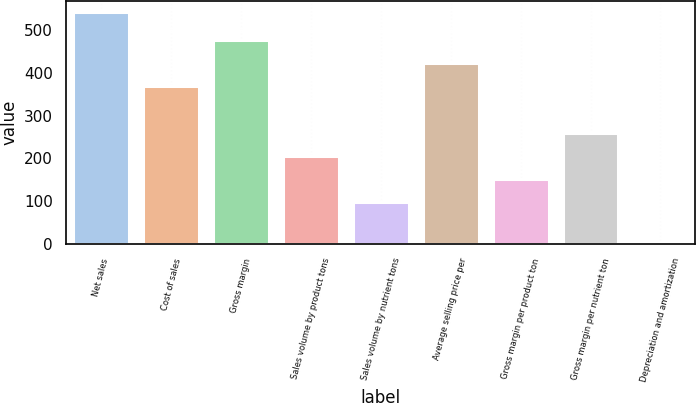Convert chart. <chart><loc_0><loc_0><loc_500><loc_500><bar_chart><fcel>Net sales<fcel>Cost of sales<fcel>Gross margin<fcel>Sales volume by product tons<fcel>Sales volume by nutrient tons<fcel>Average selling price per<fcel>Gross margin per product ton<fcel>Gross margin per nutrient ton<fcel>Depreciation and amortization<nl><fcel>542<fcel>368.5<fcel>476.7<fcel>206.2<fcel>98<fcel>422.6<fcel>152.1<fcel>260.3<fcel>1<nl></chart> 